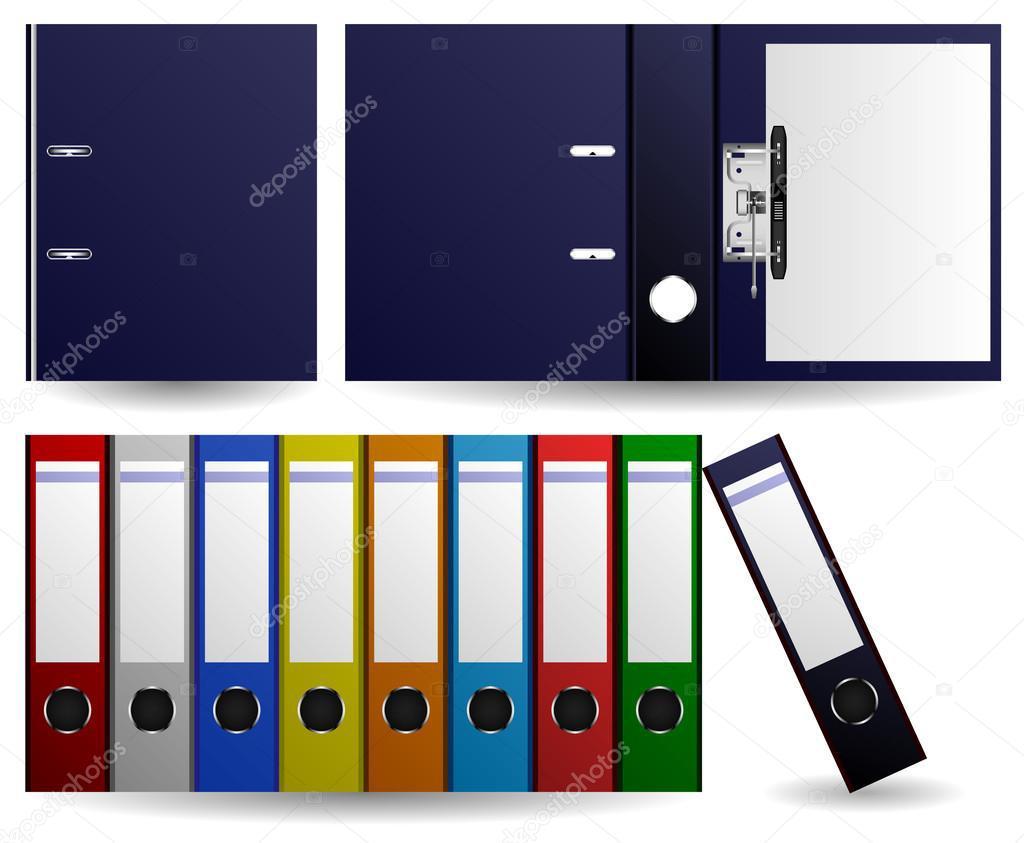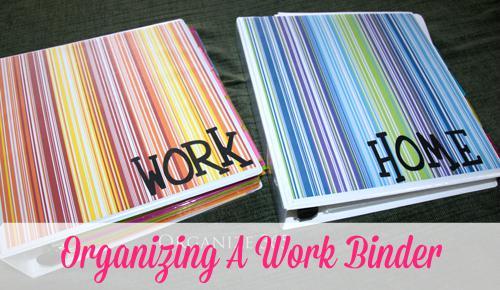The first image is the image on the left, the second image is the image on the right. Given the left and right images, does the statement "One image shows a row of different colored binders." hold true? Answer yes or no. Yes. 